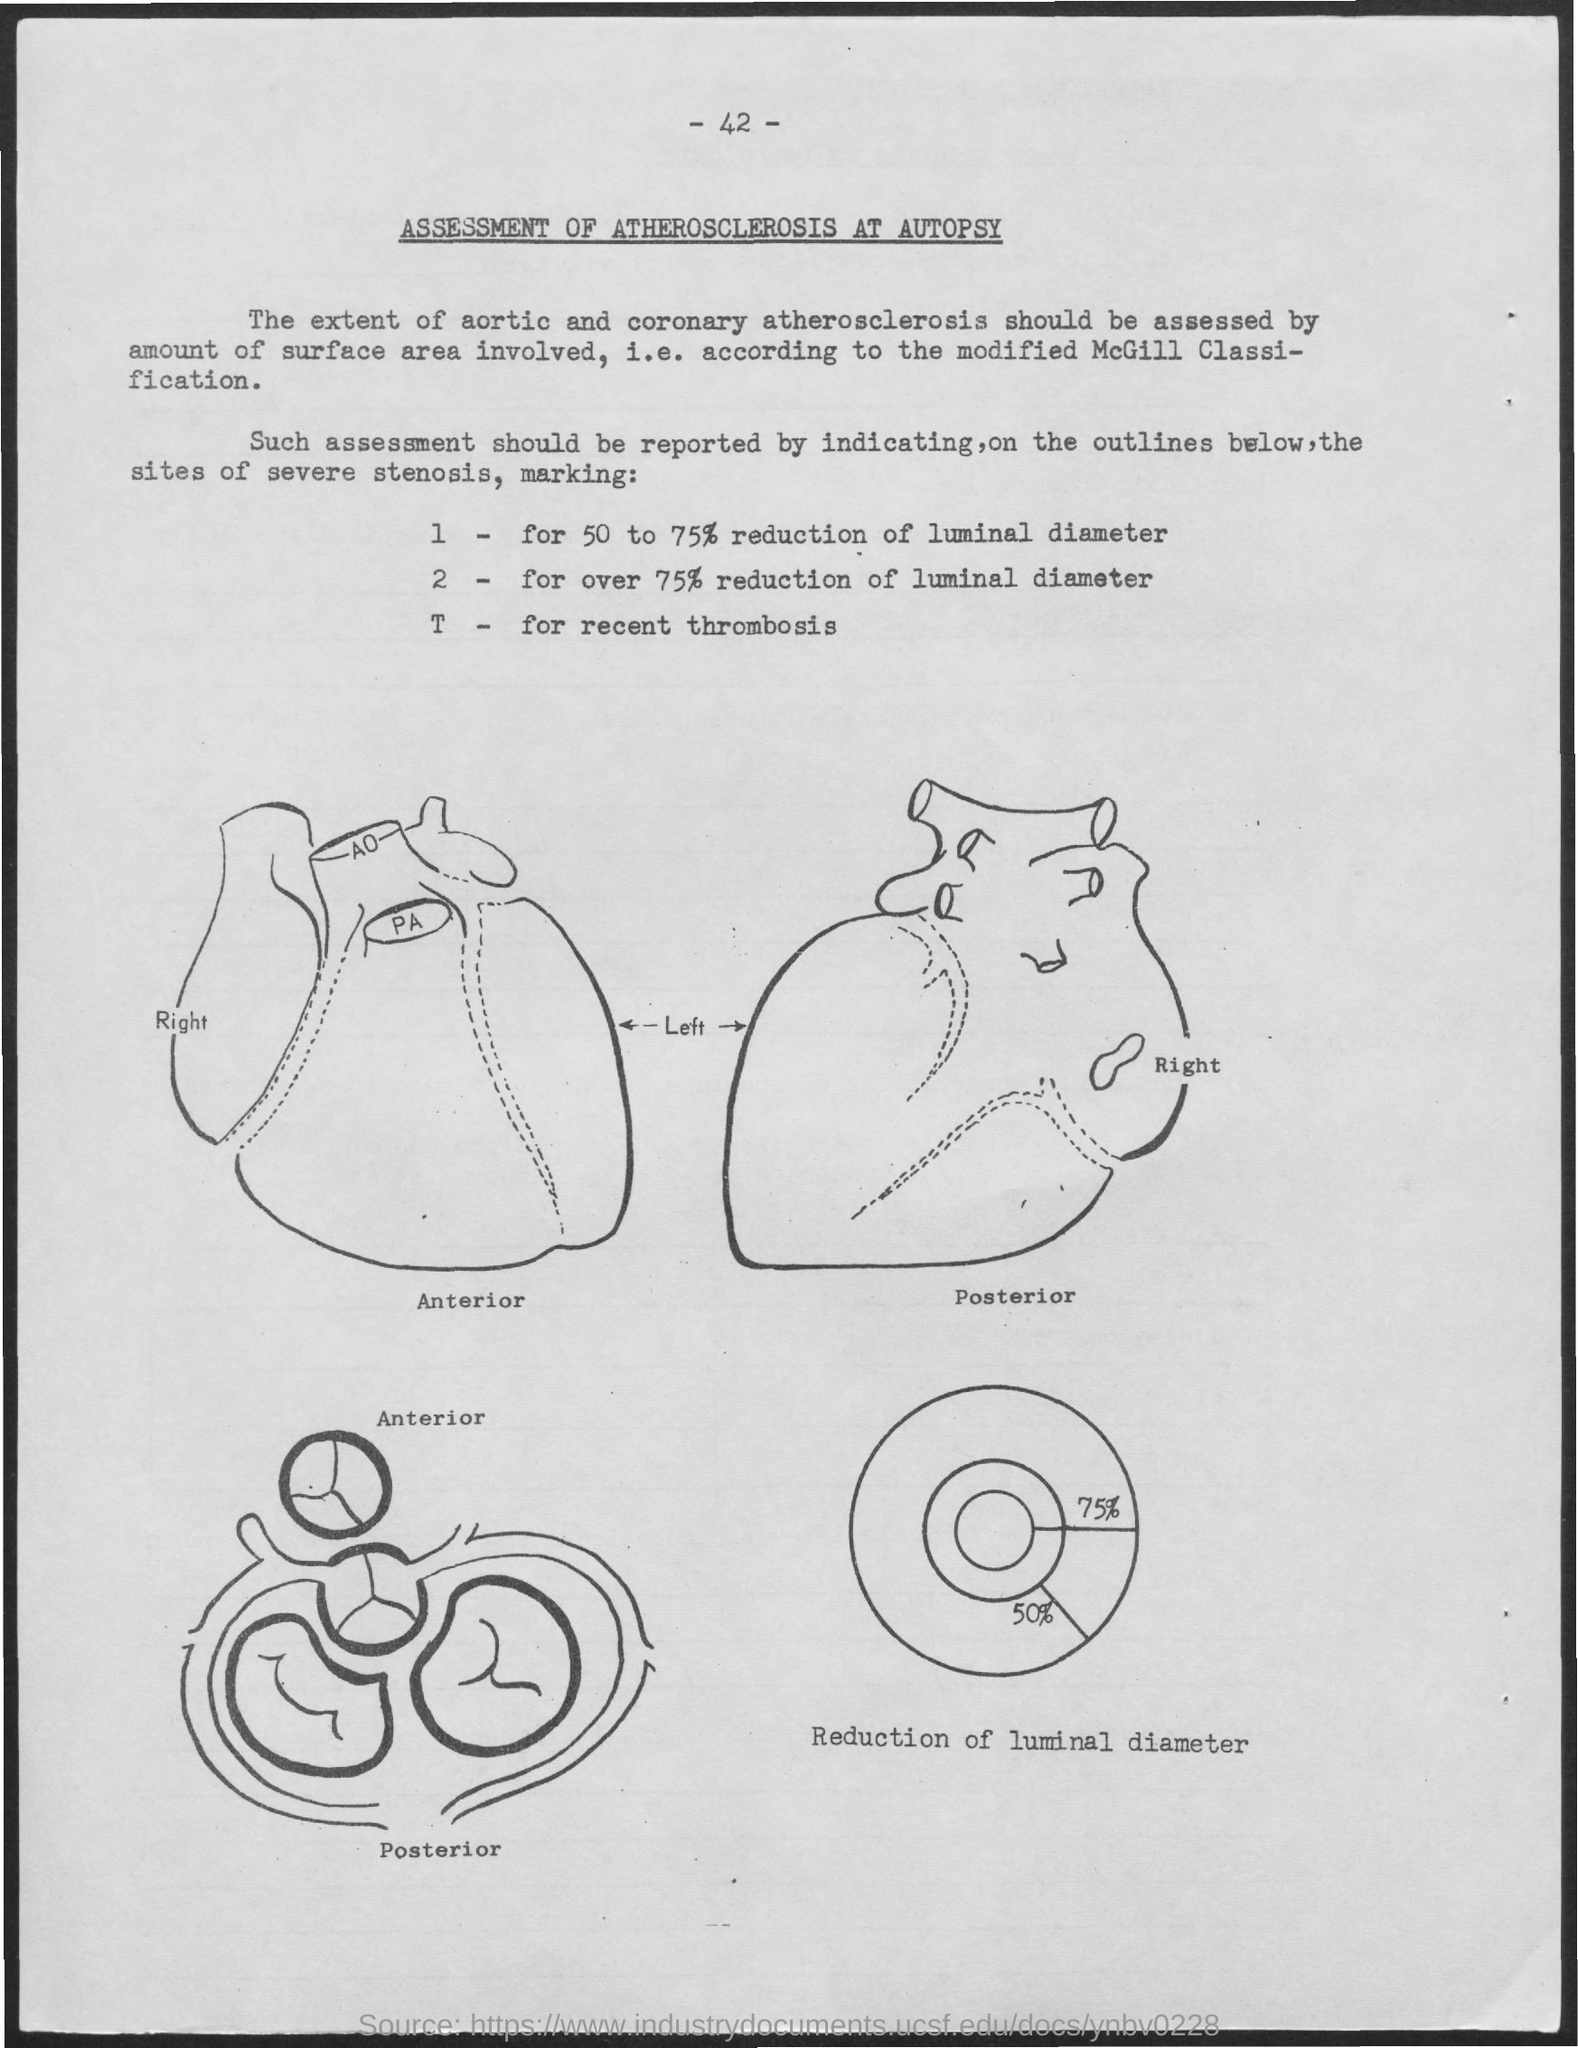What is the title of the document?
Offer a very short reply. Assessment of Atherosclerosis at autopsy. What is the Page Number?
Give a very brief answer. 42. 